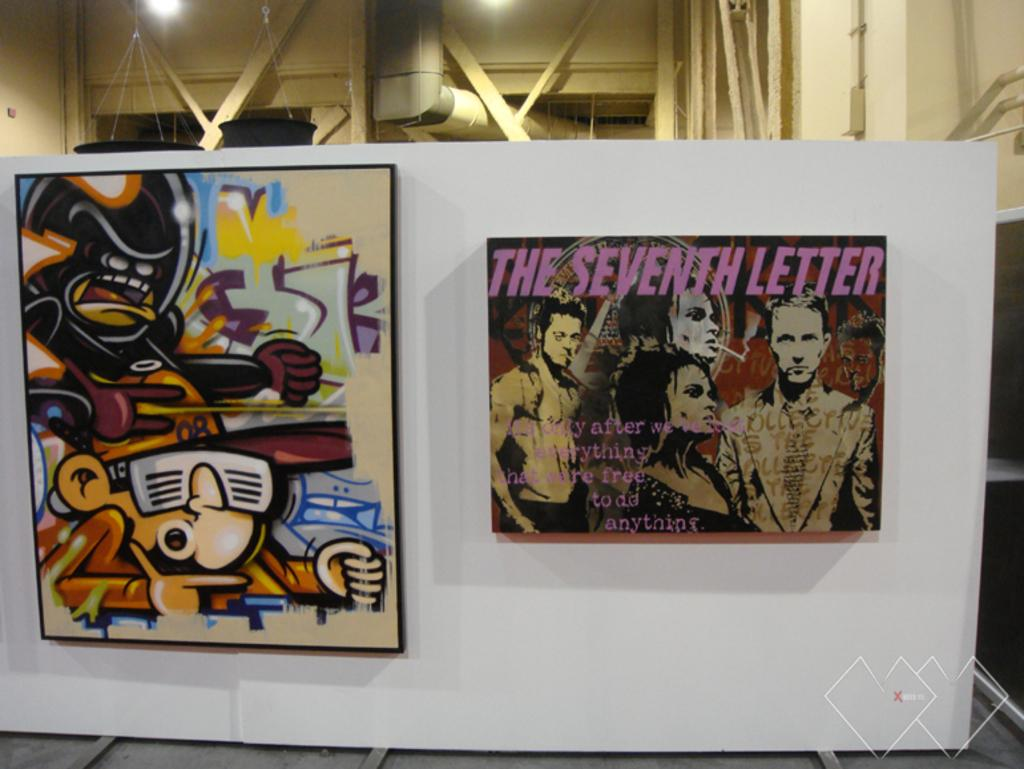<image>
Write a terse but informative summary of the picture. A poster featuring cartoon characters is setting to the left of the poster for labeled: "The Seventh Letter" 